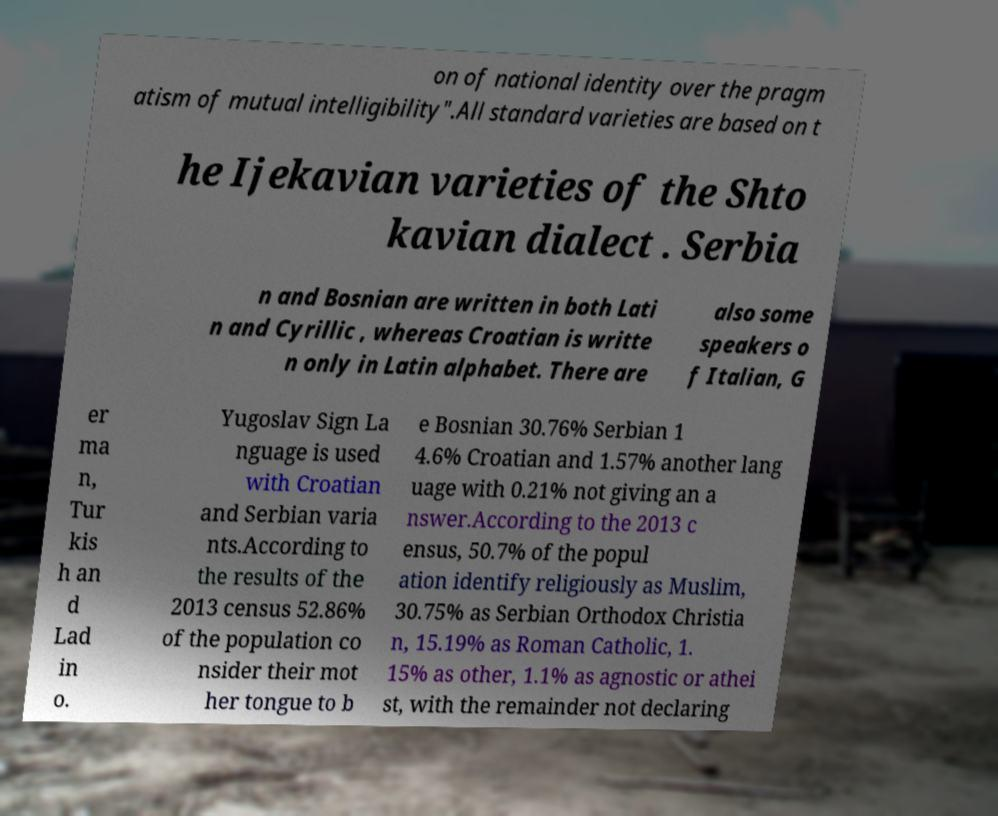Please identify and transcribe the text found in this image. on of national identity over the pragm atism of mutual intelligibility".All standard varieties are based on t he Ijekavian varieties of the Shto kavian dialect . Serbia n and Bosnian are written in both Lati n and Cyrillic , whereas Croatian is writte n only in Latin alphabet. There are also some speakers o f Italian, G er ma n, Tur kis h an d Lad in o. Yugoslav Sign La nguage is used with Croatian and Serbian varia nts.According to the results of the 2013 census 52.86% of the population co nsider their mot her tongue to b e Bosnian 30.76% Serbian 1 4.6% Croatian and 1.57% another lang uage with 0.21% not giving an a nswer.According to the 2013 c ensus, 50.7% of the popul ation identify religiously as Muslim, 30.75% as Serbian Orthodox Christia n, 15.19% as Roman Catholic, 1. 15% as other, 1.1% as agnostic or athei st, with the remainder not declaring 